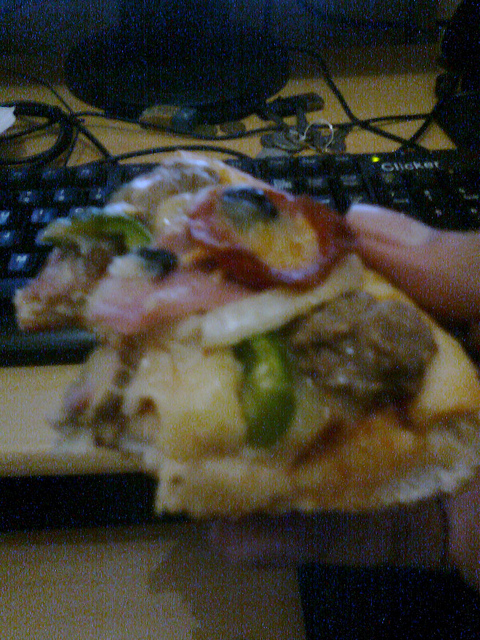Has any of this food been eaten? Yes, the slice in the foreground has clearly been bitten into at least once. 